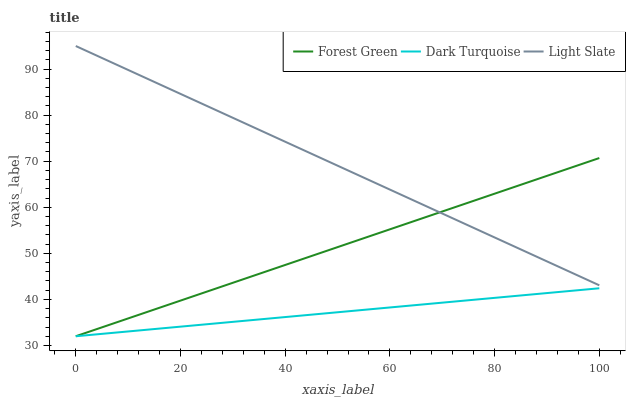Does Dark Turquoise have the minimum area under the curve?
Answer yes or no. Yes. Does Light Slate have the maximum area under the curve?
Answer yes or no. Yes. Does Forest Green have the minimum area under the curve?
Answer yes or no. No. Does Forest Green have the maximum area under the curve?
Answer yes or no. No. Is Light Slate the smoothest?
Answer yes or no. Yes. Is Forest Green the roughest?
Answer yes or no. Yes. Is Dark Turquoise the smoothest?
Answer yes or no. No. Is Dark Turquoise the roughest?
Answer yes or no. No. Does Dark Turquoise have the lowest value?
Answer yes or no. Yes. Does Light Slate have the highest value?
Answer yes or no. Yes. Does Forest Green have the highest value?
Answer yes or no. No. Is Dark Turquoise less than Light Slate?
Answer yes or no. Yes. Is Light Slate greater than Dark Turquoise?
Answer yes or no. Yes. Does Light Slate intersect Forest Green?
Answer yes or no. Yes. Is Light Slate less than Forest Green?
Answer yes or no. No. Is Light Slate greater than Forest Green?
Answer yes or no. No. Does Dark Turquoise intersect Light Slate?
Answer yes or no. No. 